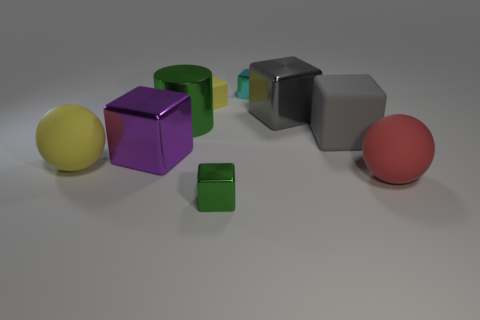Can you describe how the composition of this image might imply a certain hierarchy or relationship among the objects? Certainly! The arrangement of the objects in the image might suggest a hierarchy or a relationship based on their size and placement. The two prominently larger spheres and the purple cube appear to command more visual weight, possibly indicating a higher rank or importance, while the smaller cubes could be seen as subordinate or less dominant. The positioning also creates a visual flow, leading the viewer's eye from one object to another, suggesting a sense of connectivity or interaction amongst them. 